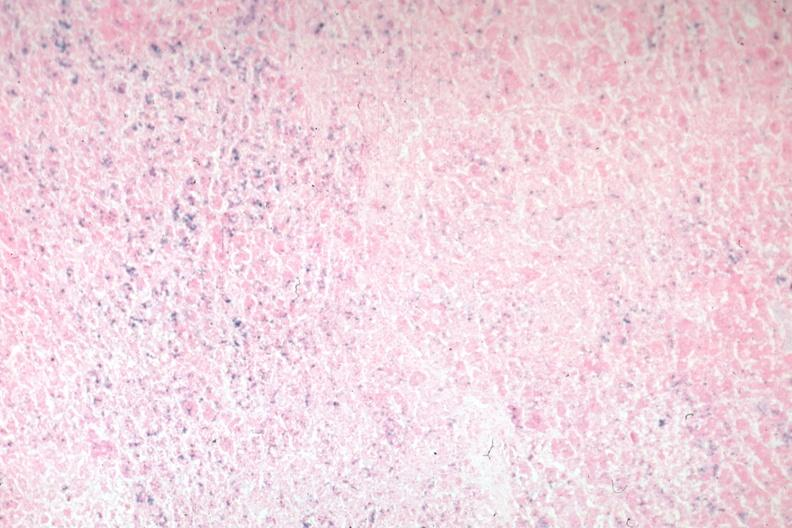does this image show iron stain?
Answer the question using a single word or phrase. Yes 